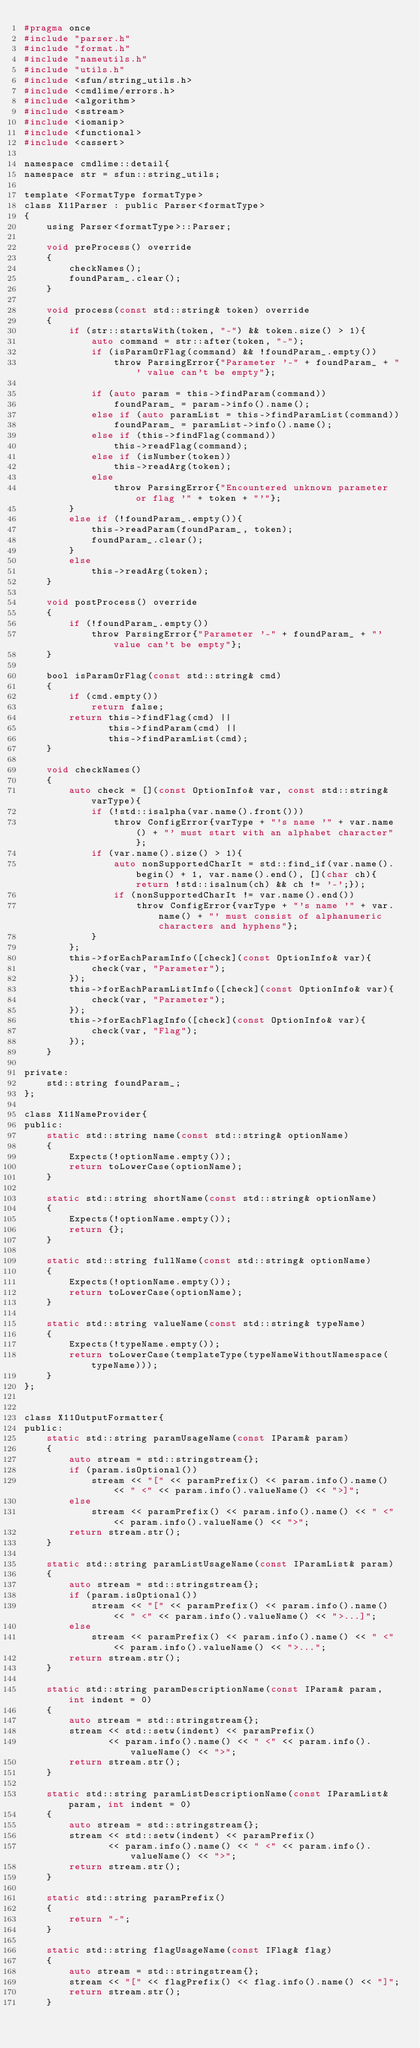<code> <loc_0><loc_0><loc_500><loc_500><_C_>#pragma once
#include "parser.h"
#include "format.h"
#include "nameutils.h"
#include "utils.h"
#include <sfun/string_utils.h>
#include <cmdlime/errors.h>
#include <algorithm>
#include <sstream>
#include <iomanip>
#include <functional>
#include <cassert>

namespace cmdlime::detail{
namespace str = sfun::string_utils;

template <FormatType formatType>
class X11Parser : public Parser<formatType>
{
    using Parser<formatType>::Parser;

    void preProcess() override
    {
        checkNames();
        foundParam_.clear();
    }

    void process(const std::string& token) override
    {        
        if (str::startsWith(token, "-") && token.size() > 1){
            auto command = str::after(token, "-");
            if (isParamOrFlag(command) && !foundParam_.empty())
                throw ParsingError{"Parameter '-" + foundParam_ + "' value can't be empty"};

            if (auto param = this->findParam(command))
                foundParam_ = param->info().name();
            else if (auto paramList = this->findParamList(command))
                foundParam_ = paramList->info().name();
            else if (this->findFlag(command))
                this->readFlag(command);
            else if (isNumber(token))
                this->readArg(token);
            else
                throw ParsingError{"Encountered unknown parameter or flag '" + token + "'"};
        }
        else if (!foundParam_.empty()){
            this->readParam(foundParam_, token);
            foundParam_.clear();
        }
        else
            this->readArg(token);
    }

    void postProcess() override
    {
        if (!foundParam_.empty())
            throw ParsingError{"Parameter '-" + foundParam_ + "' value can't be empty"};
    }

    bool isParamOrFlag(const std::string& cmd)
    {
        if (cmd.empty())
            return false;
        return this->findFlag(cmd) ||
               this->findParam(cmd) ||
               this->findParamList(cmd);
    }

    void checkNames()
    {
        auto check = [](const OptionInfo& var, const std::string& varType){
            if (!std::isalpha(var.name().front()))
                throw ConfigError{varType + "'s name '" + var.name() + "' must start with an alphabet character"};
            if (var.name().size() > 1){
                auto nonSupportedCharIt = std::find_if(var.name().begin() + 1, var.name().end(), [](char ch){return !std::isalnum(ch) && ch != '-';});
                if (nonSupportedCharIt != var.name().end())
                    throw ConfigError{varType + "'s name '" + var.name() + "' must consist of alphanumeric characters and hyphens"};
            }
        };
        this->forEachParamInfo([check](const OptionInfo& var){
            check(var, "Parameter");
        });
        this->forEachParamListInfo([check](const OptionInfo& var){
            check(var, "Parameter");
        });
        this->forEachFlagInfo([check](const OptionInfo& var){
            check(var, "Flag");
        });
    }

private:
    std::string foundParam_;
};

class X11NameProvider{
public:
    static std::string name(const std::string& optionName)
    {
        Expects(!optionName.empty());
        return toLowerCase(optionName);
    }

    static std::string shortName(const std::string& optionName)
    {
        Expects(!optionName.empty());
        return {};
    }

    static std::string fullName(const std::string& optionName)
    {
        Expects(!optionName.empty());
        return toLowerCase(optionName);
    }

    static std::string valueName(const std::string& typeName)
    {
        Expects(!typeName.empty());
        return toLowerCase(templateType(typeNameWithoutNamespace(typeName)));
    }
};


class X11OutputFormatter{
public:
    static std::string paramUsageName(const IParam& param)
    {
        auto stream = std::stringstream{};
        if (param.isOptional())
            stream << "[" << paramPrefix() << param.info().name() << " <" << param.info().valueName() << ">]";
        else
            stream << paramPrefix() << param.info().name() << " <" << param.info().valueName() << ">";
        return stream.str();
    }

    static std::string paramListUsageName(const IParamList& param)
    {
        auto stream = std::stringstream{};
        if (param.isOptional())
            stream << "[" << paramPrefix() << param.info().name() << " <" << param.info().valueName() << ">...]";
        else
            stream << paramPrefix() << param.info().name() << " <" << param.info().valueName() << ">...";
        return stream.str();
    }

    static std::string paramDescriptionName(const IParam& param, int indent = 0)
    {
        auto stream = std::stringstream{};
        stream << std::setw(indent) << paramPrefix()
               << param.info().name() << " <" << param.info().valueName() << ">";
        return stream.str();
    }

    static std::string paramListDescriptionName(const IParamList& param, int indent = 0)
    {
        auto stream = std::stringstream{};
        stream << std::setw(indent) << paramPrefix()
               << param.info().name() << " <" << param.info().valueName() << ">";
        return stream.str();
    }

    static std::string paramPrefix()
    {
        return "-";
    }

    static std::string flagUsageName(const IFlag& flag)
    {
        auto stream = std::stringstream{};
        stream << "[" << flagPrefix() << flag.info().name() << "]";
        return stream.str();
    }
</code> 